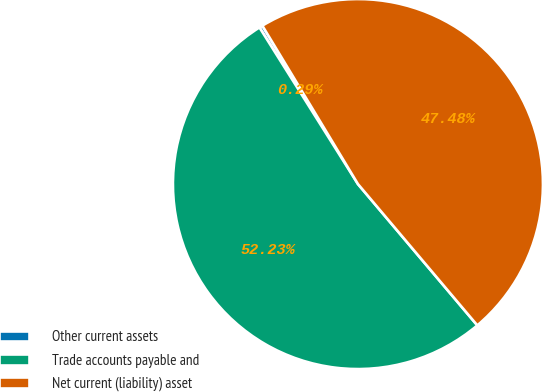<chart> <loc_0><loc_0><loc_500><loc_500><pie_chart><fcel>Other current assets<fcel>Trade accounts payable and<fcel>Net current (liability) asset<nl><fcel>0.29%<fcel>52.23%<fcel>47.48%<nl></chart> 